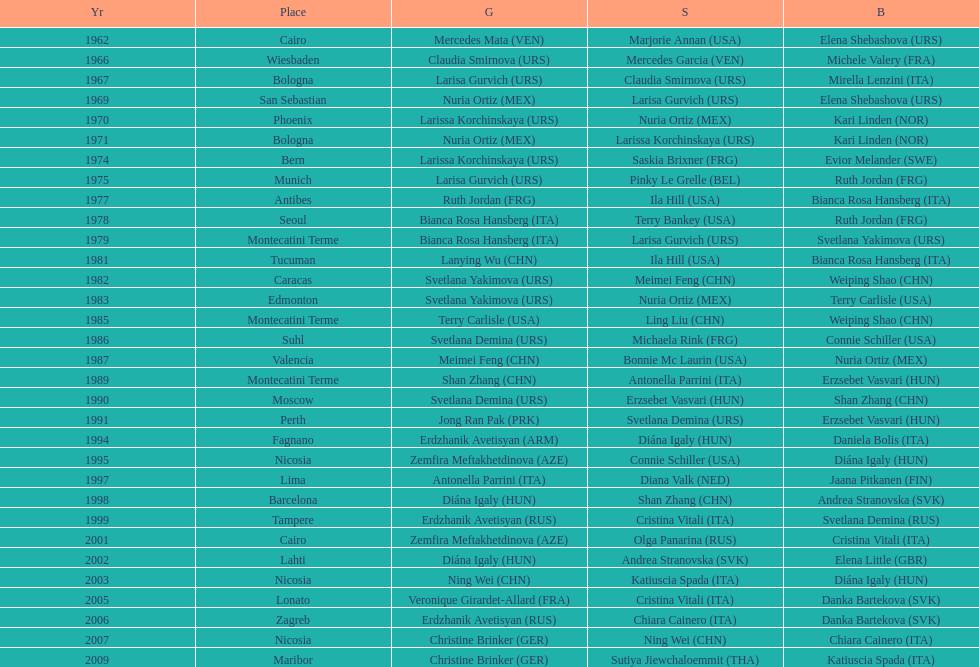Which country has won more gold medals: china or mexico? China. 